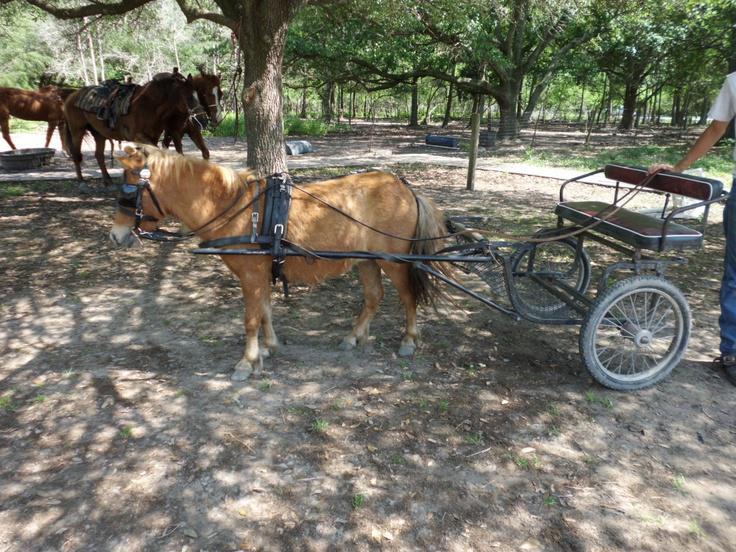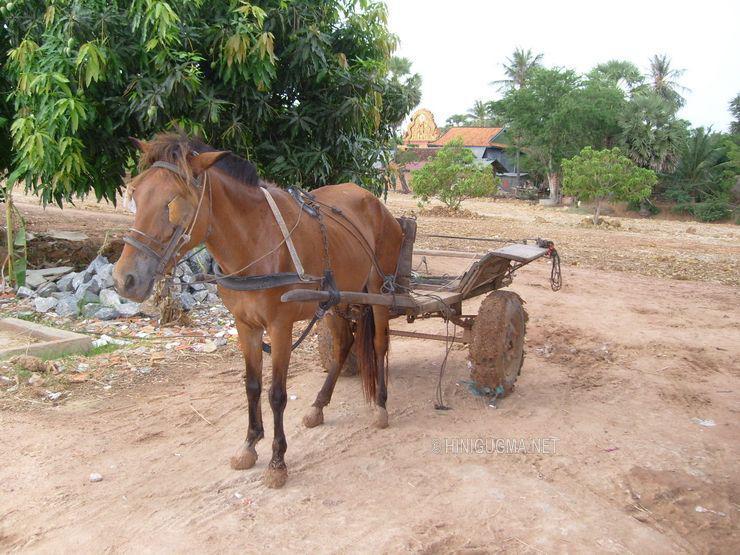The first image is the image on the left, the second image is the image on the right. Assess this claim about the two images: "In one image, carts with fabric canopies are pulled through the woods along a metal track by a single horse.". Correct or not? Answer yes or no. No. The first image is the image on the left, the second image is the image on the right. Examine the images to the left and right. Is the description "At least one image shows a cart pulled by two horses." accurate? Answer yes or no. No. 